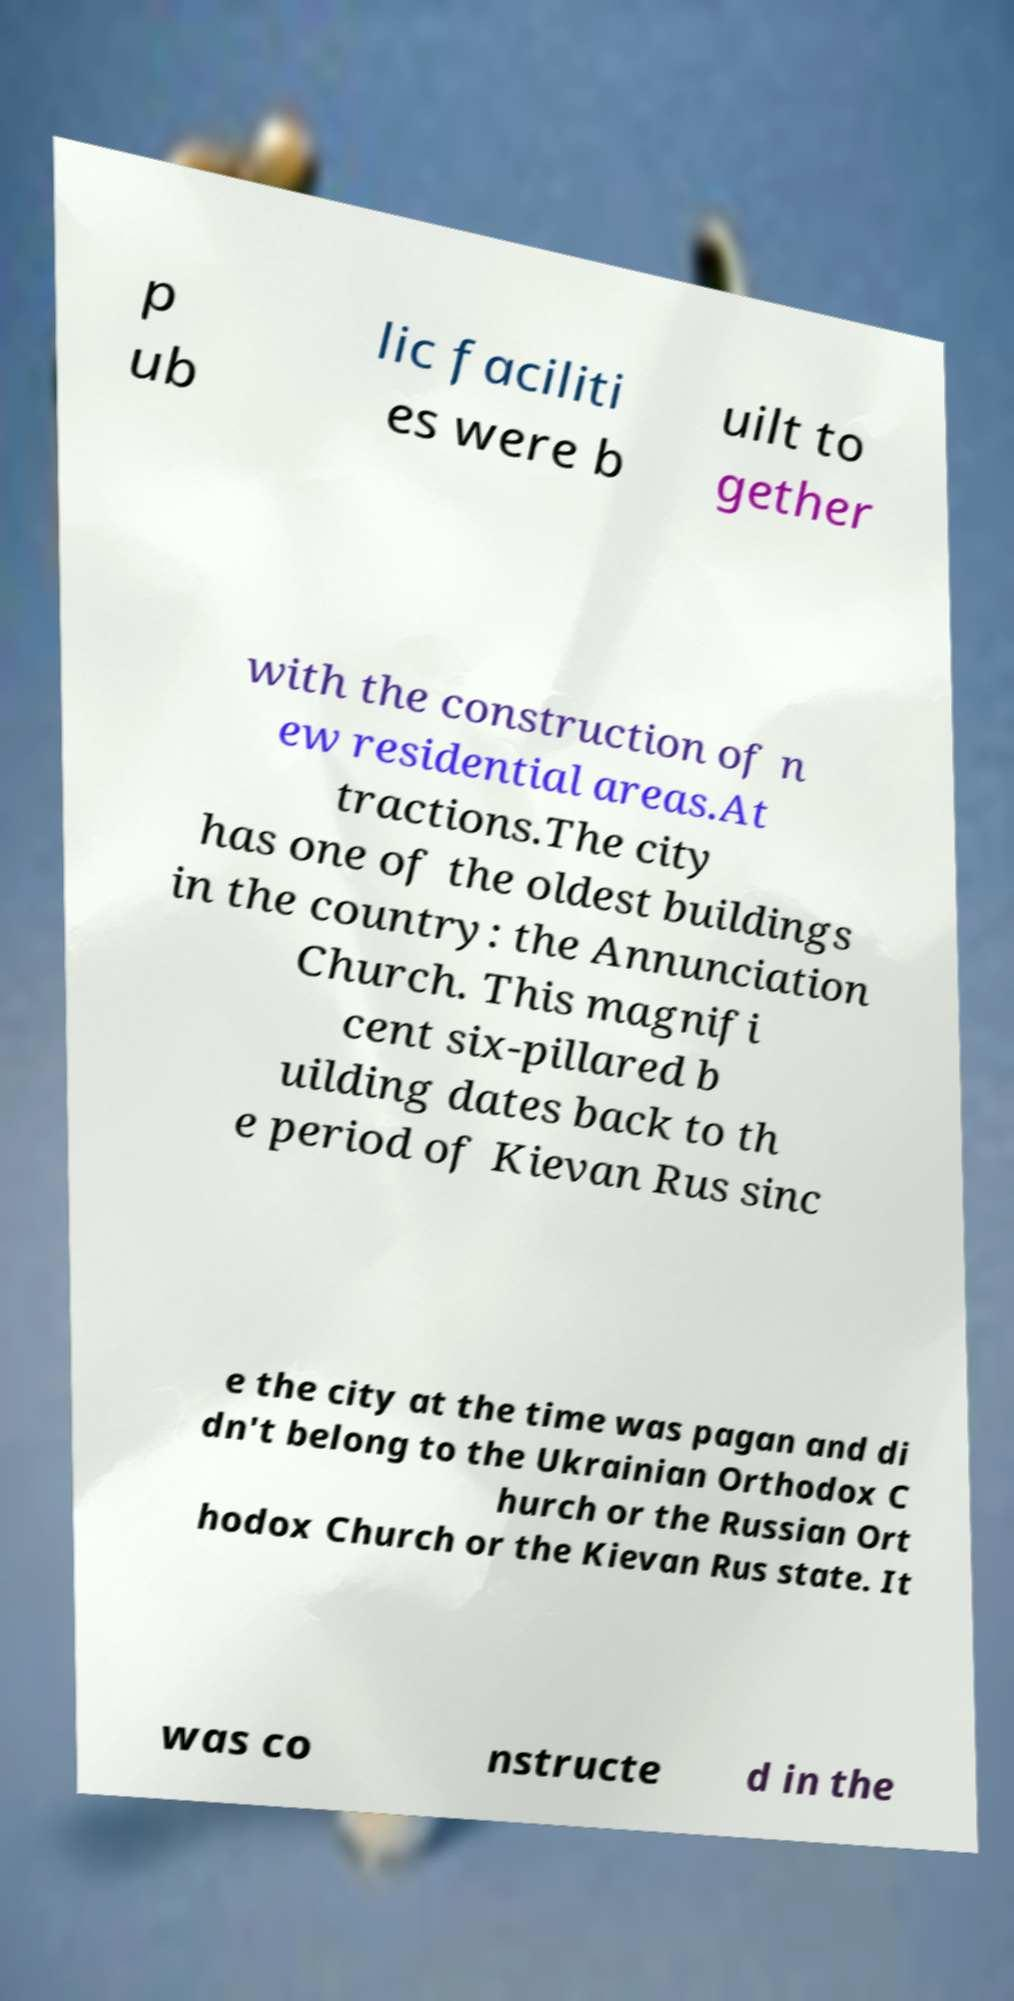What messages or text are displayed in this image? I need them in a readable, typed format. p ub lic faciliti es were b uilt to gether with the construction of n ew residential areas.At tractions.The city has one of the oldest buildings in the country: the Annunciation Church. This magnifi cent six-pillared b uilding dates back to th e period of Kievan Rus sinc e the city at the time was pagan and di dn't belong to the Ukrainian Orthodox C hurch or the Russian Ort hodox Church or the Kievan Rus state. It was co nstructe d in the 